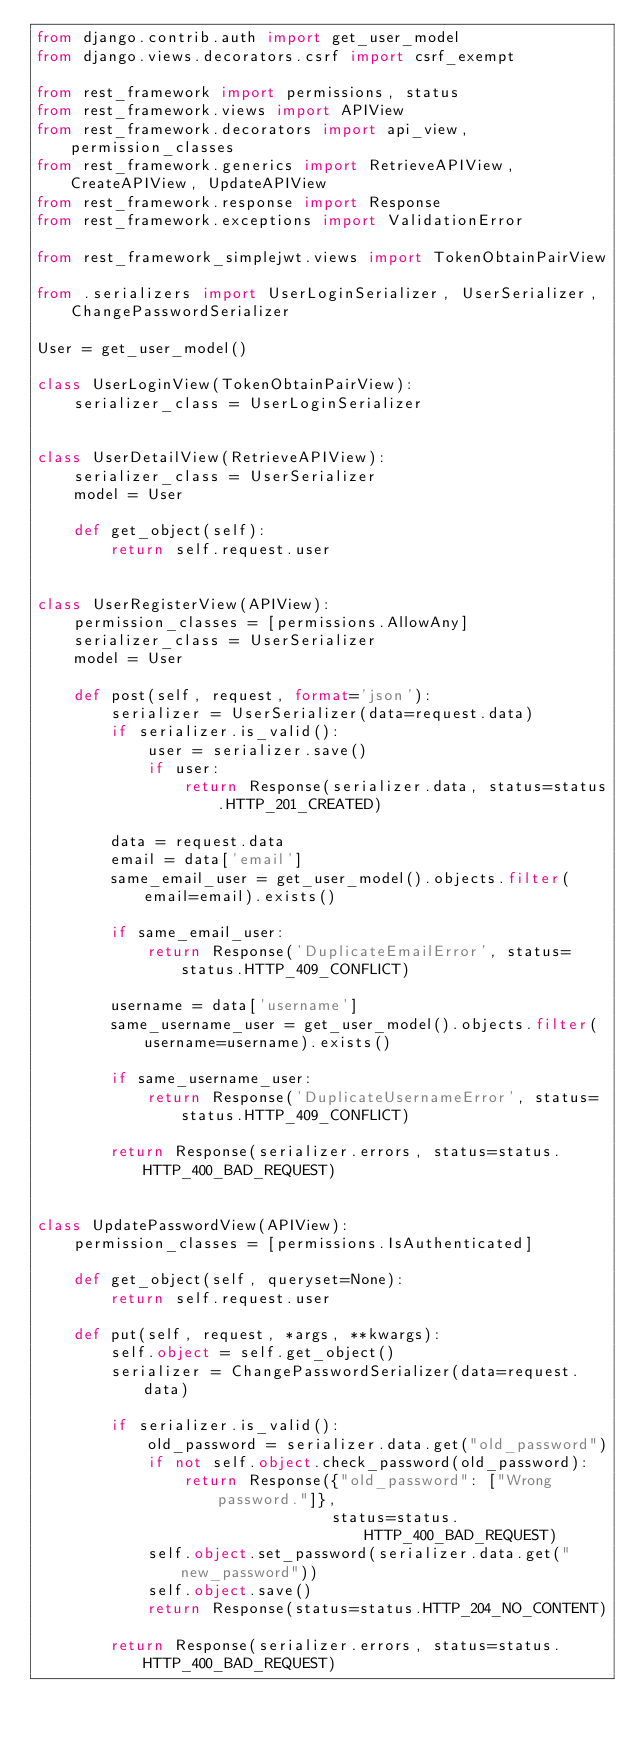<code> <loc_0><loc_0><loc_500><loc_500><_Python_>from django.contrib.auth import get_user_model
from django.views.decorators.csrf import csrf_exempt

from rest_framework import permissions, status
from rest_framework.views import APIView
from rest_framework.decorators import api_view, permission_classes
from rest_framework.generics import RetrieveAPIView, CreateAPIView, UpdateAPIView
from rest_framework.response import Response
from rest_framework.exceptions import ValidationError

from rest_framework_simplejwt.views import TokenObtainPairView

from .serializers import UserLoginSerializer, UserSerializer, ChangePasswordSerializer

User = get_user_model()

class UserLoginView(TokenObtainPairView):
    serializer_class = UserLoginSerializer


class UserDetailView(RetrieveAPIView):
    serializer_class = UserSerializer
    model = User

    def get_object(self):
        return self.request.user


class UserRegisterView(APIView):
    permission_classes = [permissions.AllowAny]
    serializer_class = UserSerializer
    model = User

    def post(self, request, format='json'):
        serializer = UserSerializer(data=request.data)
        if serializer.is_valid():
            user = serializer.save()
            if user:
                return Response(serializer.data, status=status.HTTP_201_CREATED)
        
        data = request.data
        email = data['email']
        same_email_user = get_user_model().objects.filter(email=email).exists()

        if same_email_user:
            return Response('DuplicateEmailError', status=status.HTTP_409_CONFLICT)

        username = data['username']
        same_username_user = get_user_model().objects.filter(username=username).exists()
        
        if same_username_user:
            return Response('DuplicateUsernameError', status=status.HTTP_409_CONFLICT)

        return Response(serializer.errors, status=status.HTTP_400_BAD_REQUEST)


class UpdatePasswordView(APIView):
    permission_classes = [permissions.IsAuthenticated]

    def get_object(self, queryset=None):
        return self.request.user

    def put(self, request, *args, **kwargs):
        self.object = self.get_object()
        serializer = ChangePasswordSerializer(data=request.data)

        if serializer.is_valid():
            old_password = serializer.data.get("old_password")
            if not self.object.check_password(old_password):
                return Response({"old_password": ["Wrong password."]}, 
                                status=status.HTTP_400_BAD_REQUEST)
            self.object.set_password(serializer.data.get("new_password"))
            self.object.save()
            return Response(status=status.HTTP_204_NO_CONTENT)

        return Response(serializer.errors, status=status.HTTP_400_BAD_REQUEST)
</code> 